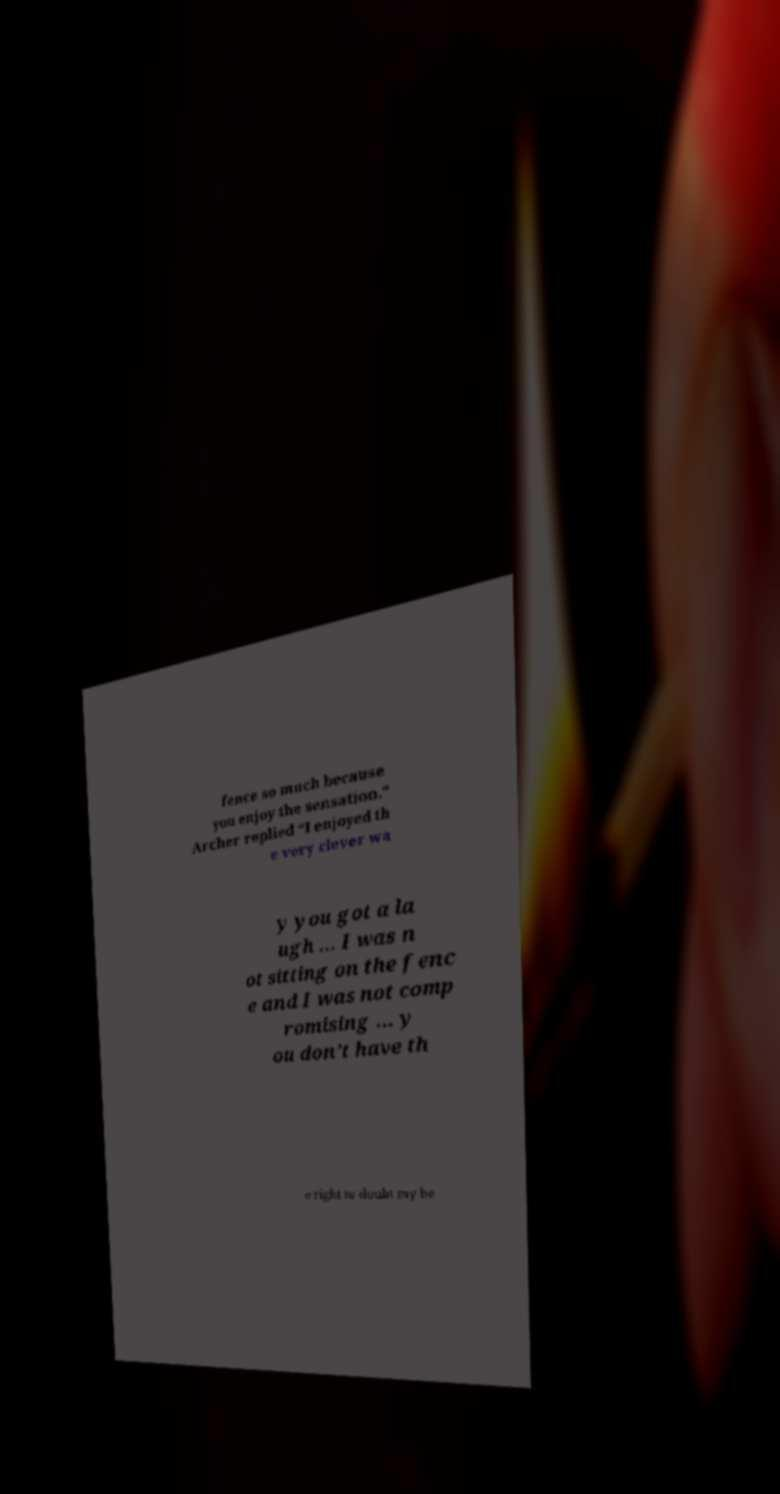Can you read and provide the text displayed in the image?This photo seems to have some interesting text. Can you extract and type it out for me? fence so much because you enjoy the sensation." Archer replied “I enjoyed th e very clever wa y you got a la ugh … I was n ot sitting on the fenc e and I was not comp romising ... y ou don’t have th e right to doubt my be 